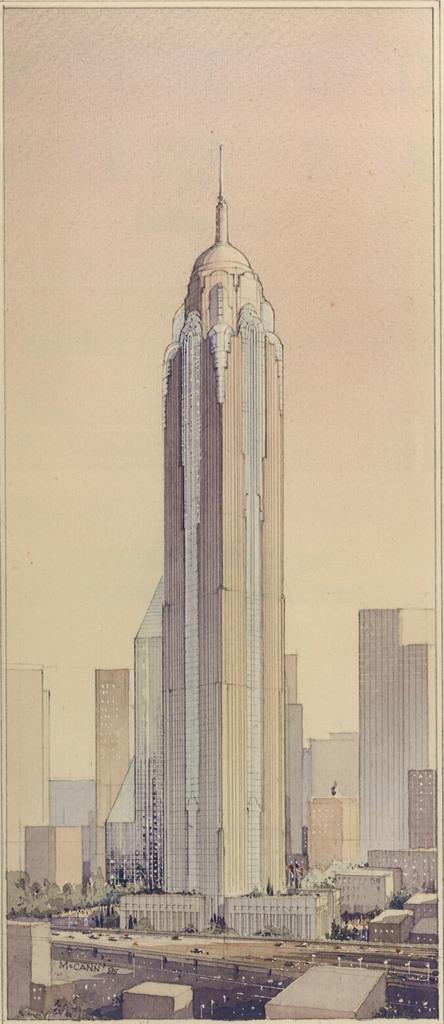What can be seen in the foreground of the image? In the foreground, there are vehicles on the road, light poles, trees, buildings, and towers. What is visible in the background of the image? The sky is visible in the background of the image. What time of day was the image taken? The image was taken during the day. What type of steel is used to construct the locket in the image? There is no locket present in the image, so it is not possible to determine the type of steel used in its construction. 